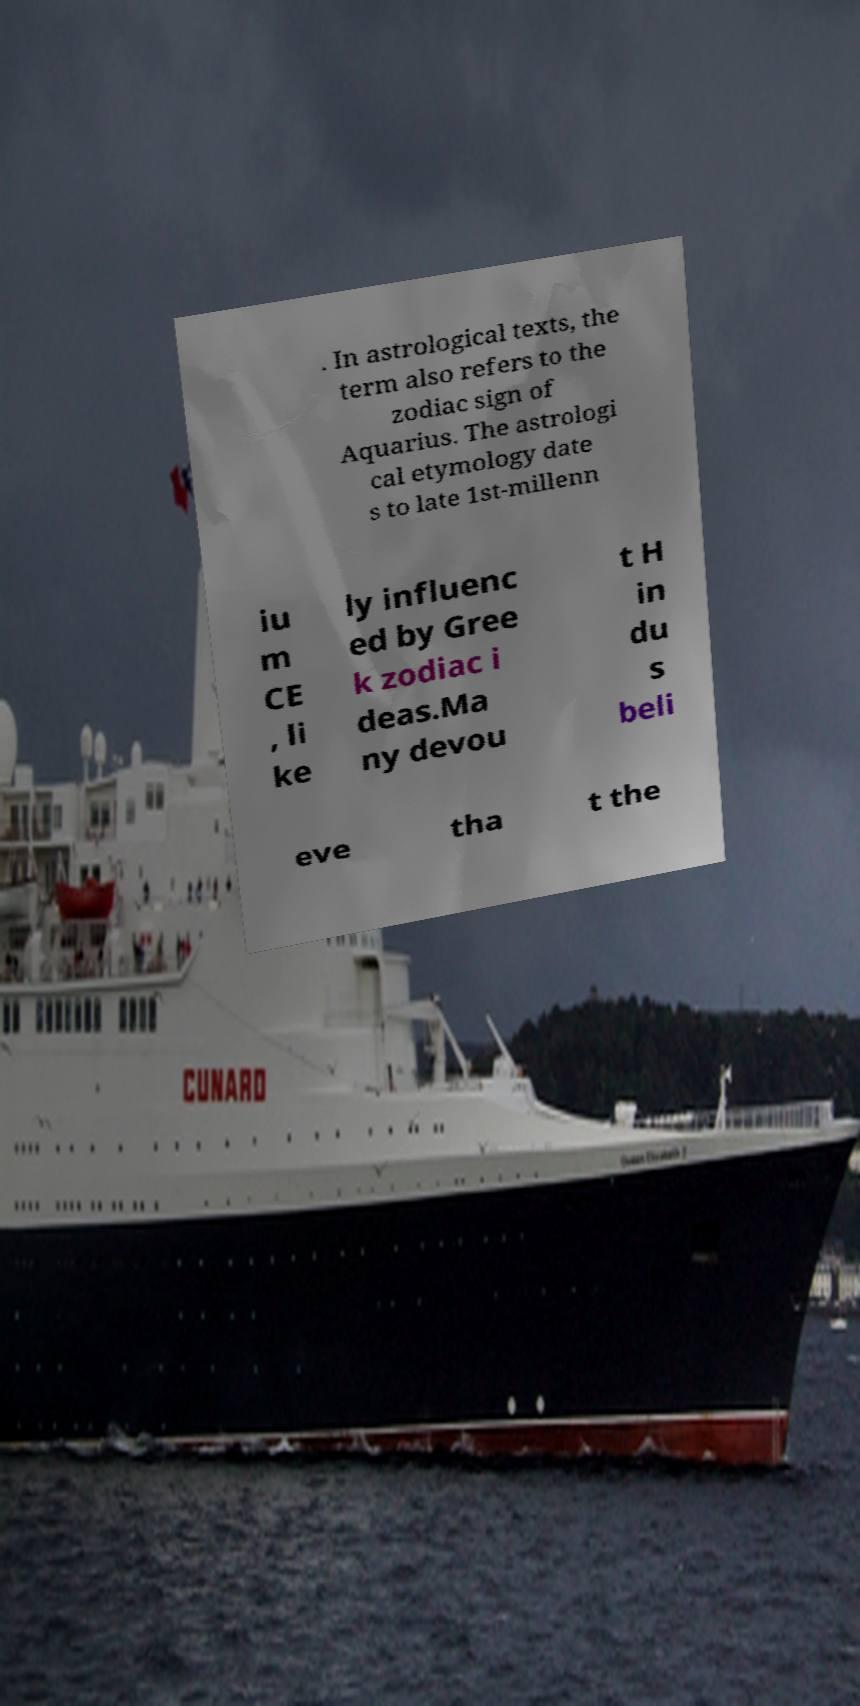What messages or text are displayed in this image? I need them in a readable, typed format. . In astrological texts, the term also refers to the zodiac sign of Aquarius. The astrologi cal etymology date s to late 1st-millenn iu m CE , li ke ly influenc ed by Gree k zodiac i deas.Ma ny devou t H in du s beli eve tha t the 